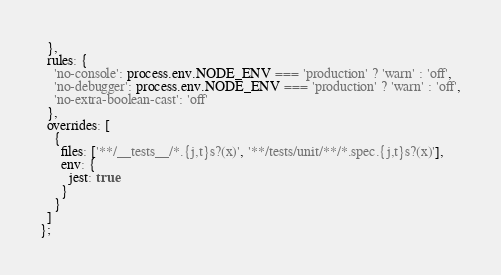<code> <loc_0><loc_0><loc_500><loc_500><_JavaScript_>  },
  rules: {
    'no-console': process.env.NODE_ENV === 'production' ? 'warn' : 'off',
    'no-debugger': process.env.NODE_ENV === 'production' ? 'warn' : 'off',
    'no-extra-boolean-cast': 'off'
  },
  overrides: [
    {
      files: ['**/__tests__/*.{j,t}s?(x)', '**/tests/unit/**/*.spec.{j,t}s?(x)'],
      env: {
        jest: true
      }
    }
  ]
};
</code> 